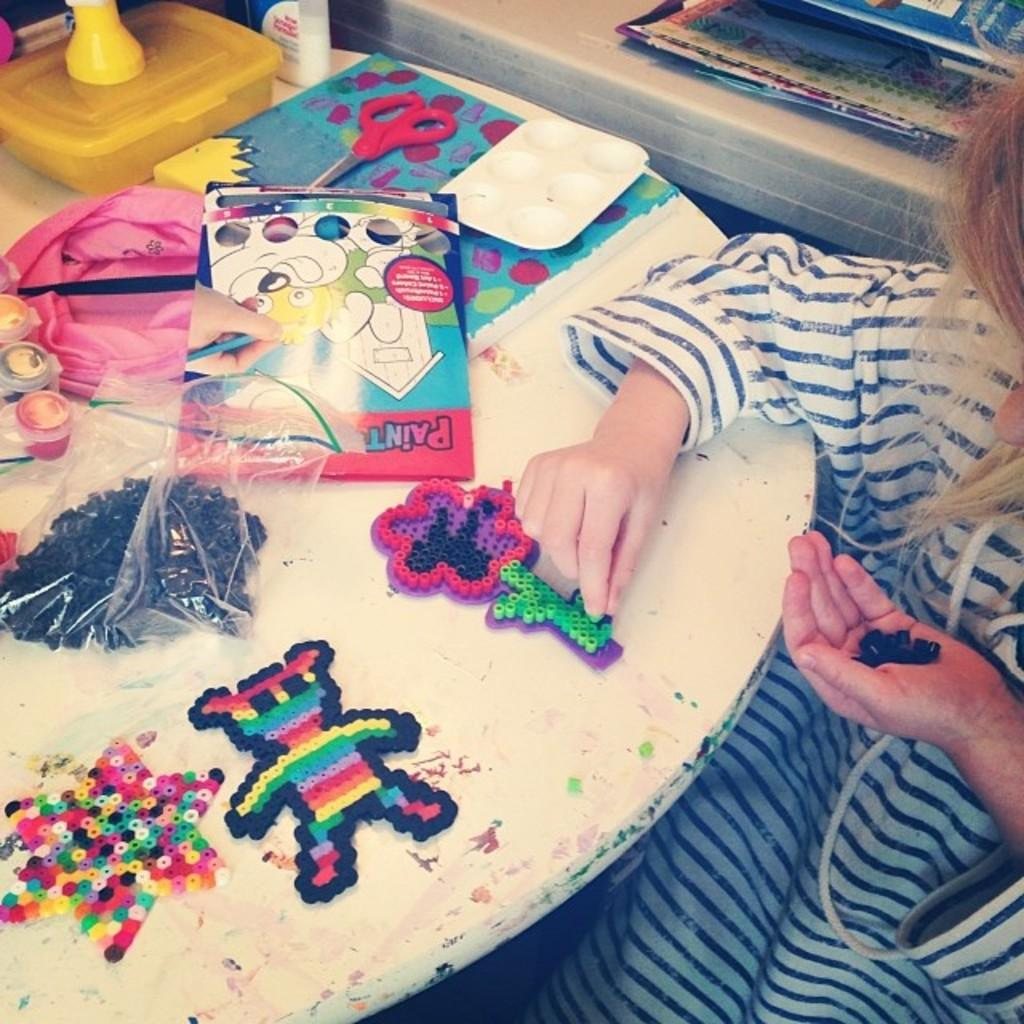What objects are on the table in the image? There are toys on a table in the image. Where is the girl located in the image? The girl is sitting on the right side of the image. What type of suit is the girl's dad wearing in the image? There is no dad or suit present in the image; it only features a girl sitting on the right side of the image and toys on a table. Can you tell me how many needles are visible in the image? There are no needles present in the image. 